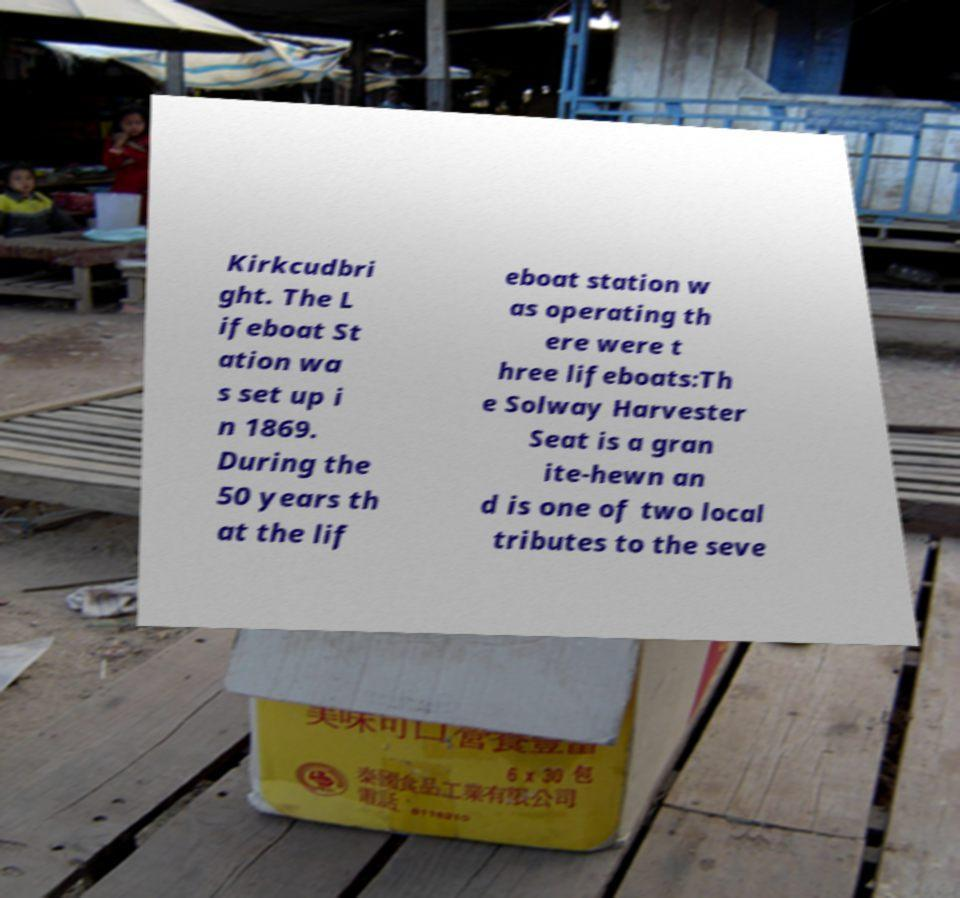Could you assist in decoding the text presented in this image and type it out clearly? Kirkcudbri ght. The L ifeboat St ation wa s set up i n 1869. During the 50 years th at the lif eboat station w as operating th ere were t hree lifeboats:Th e Solway Harvester Seat is a gran ite-hewn an d is one of two local tributes to the seve 